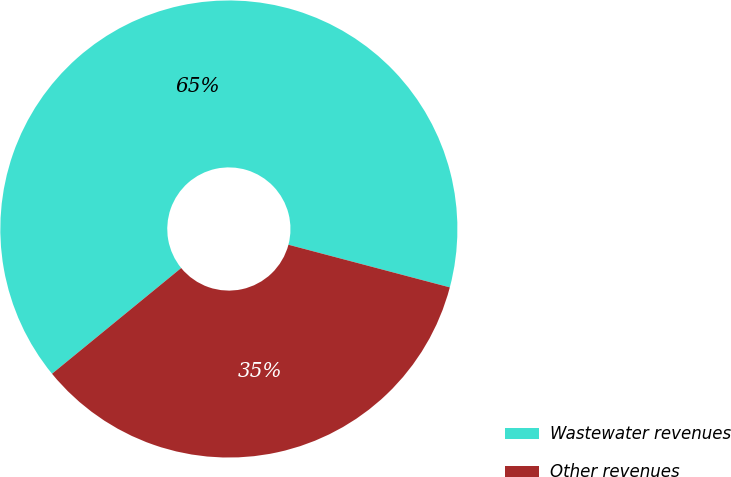Convert chart to OTSL. <chart><loc_0><loc_0><loc_500><loc_500><pie_chart><fcel>Wastewater revenues<fcel>Other revenues<nl><fcel>65.03%<fcel>34.97%<nl></chart> 